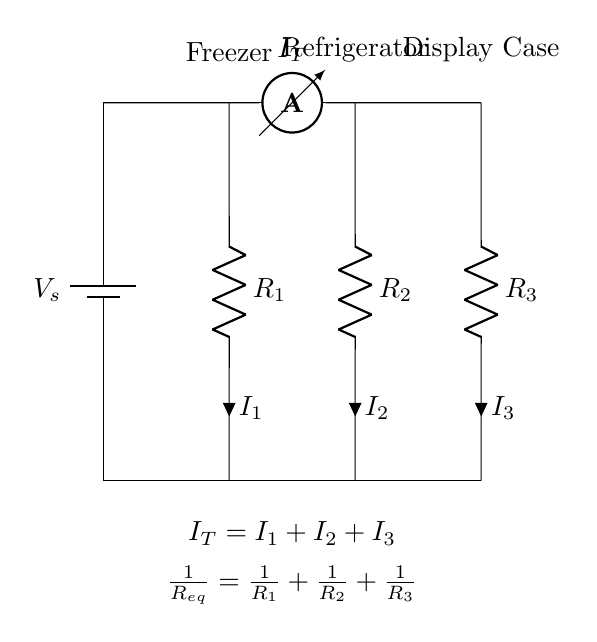What is the total current in the circuit? The total current is represented by I_T in the circuit, which is the sum of all branch currents (I_1, I_2, I_3). Thus, I_T = I_1 + I_2 + I_3, showing that all currents combine at the junction.
Answer: I_T How many parallel branches are there? The diagram shows three distinct parallel branches where the components (R_1, R_2, R_3) are connected alongside each other, indicating three paths for current to flow.
Answer: Three What components are used in this circuit? The components in this circuit include a battery (voltage source), three resistors (R_1, R_2, R_3 representing the freezer, refrigerator, and display case), and an ammeter. Each component is labeled accordingly in the diagram.
Answer: Battery, Resistors What is the equivalent resistance formula for the circuit? The equivalent resistance for components in parallel is calculated using the formula 1/R_eq = 1/R_1 + 1/R_2 + 1/R_3. This calculates the combined effect of all resistors when connected in a parallel arrangement.
Answer: 1/R_eq = 1/R_1 + 1/R_2 + 1/R_3 If R_1 is 10 ohms, R_2 is 20 ohms, and R_3 is 30 ohms, what is the equivalent resistance? To calculate equivalent resistance, substitute the values into the formula: 1/R_eq = 1/10 + 1/20 + 1/30. The calculation proceeds as follows: 1/R_eq = 0.1 + 0.05 + 0.0333 = 0.1833, thus R_eq = 5.46 ohms (approximate).
Answer: 5.46 ohms Which branch has the highest current? Since current divides inversely with resistance in parallel circuits, the branch with the lowest resistance will have the highest current. Therefore, the branch with R_1 (the freezer at 10 ohms) will have the highest current, as it offers the least resistance.
Answer: R_1 